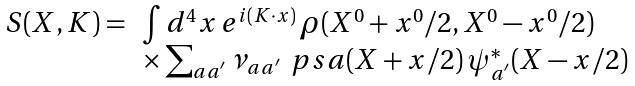<formula> <loc_0><loc_0><loc_500><loc_500>\begin{array} { l l } S ( X , K ) = & \int d ^ { 4 } x \, e ^ { i ( K \cdot x ) } \, \rho ( X ^ { 0 } + x ^ { 0 } / 2 , X ^ { 0 } - x ^ { 0 } / 2 ) \\ & \times \sum _ { a a ^ { ^ { \prime } } } \nu _ { a a ^ { ^ { \prime } } } \, \ p s a ( X + x / 2 ) \, \psi ^ { * } _ { a ^ { ^ { \prime } } } ( X - x / 2 ) \end{array}</formula> 